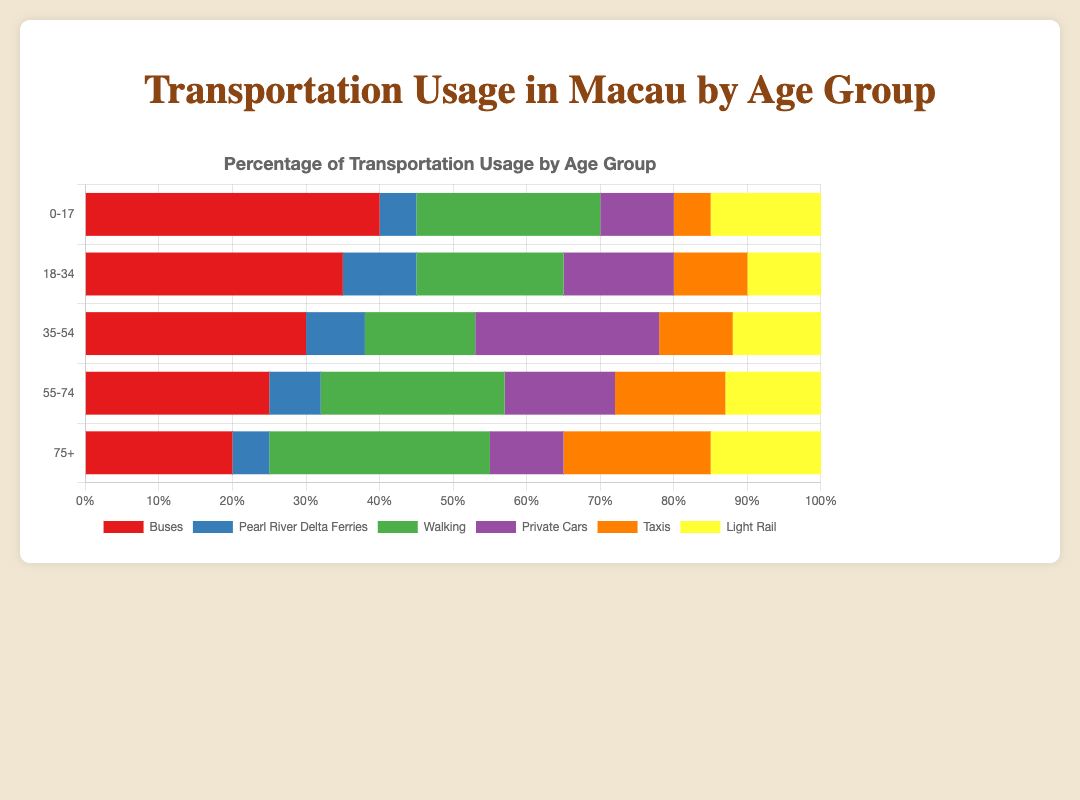Which age group uses buses the most? The age group '0-17' has the highest percentage for bus usage, as seen by the longest red bar.
Answer: 0-17 Which mode of transport has the highest usage among the '75+' age group? The segment representing 'Walking' is the longest for the '75+' age group, indicating it is the most used mode.
Answer: Walking By how much does the usage of private cars differ between the '18-34' and '35-54' age groups? The '18-34' age group has a 15% usage of private cars while the '35-54' age group has a 25% usage. The difference is 25% - 15% = 10%.
Answer: 10% How does the use of Pearl River Delta Ferries compare between the '0-17' and '18-34' age groups? The '0-17' age group uses Pearl River Delta Ferries 5% while the '18-34' age group uses it 10%. The '18-34' group uses it more by 10% - 5% = 5%.
Answer: The '18-34' group uses it 5% more Which age group has the least usage of taxis? The age group '0-17' has the shortest segment for taxis, indicating the least usage.
Answer: 0-17 What is the combined percentage usage of light rail and private cars for the '55-74' age group? The '55-74' age group's usage of light rail is 13% and private cars is 15%. The combined percentage is 13% + 15% = 28%.
Answer: 28% Is the percentage of people who walk higher for the '75+' age group compared to the '55-74' age group? For the '75+' age group, walking percentage is 30%, whereas for '55-74' it is 25%. Therefore, it is higher for the '75+' group by 30% - 25% = 5%.
Answer: Yes, 5% higher Which two modes of transport have the closest usage percentages for the '18-34' age group? For the '18-34' age group, walking and light rail both have a usage of 20% and 10%, respectively. The closest percentages are light rail (10%) and Pearl River Delta Ferries (10%).
Answer: Light Rail and Pearl River Delta Ferries 